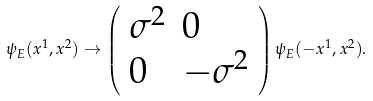<formula> <loc_0><loc_0><loc_500><loc_500>\psi _ { E } ( x ^ { 1 } , x ^ { 2 } ) \rightarrow \left ( \begin{array} { l l } { { \sigma ^ { 2 } } } & { 0 } \\ { 0 } & { { - \sigma ^ { 2 } } } \end{array} \right ) \psi _ { E } ( - x ^ { 1 } , x ^ { 2 } ) .</formula> 